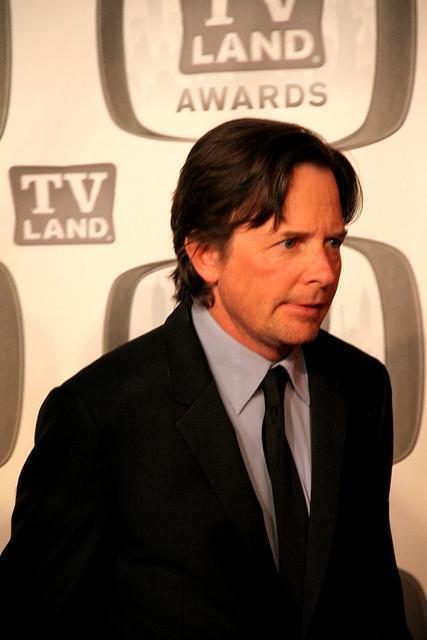How many trucks are there?
Give a very brief answer. 0. 